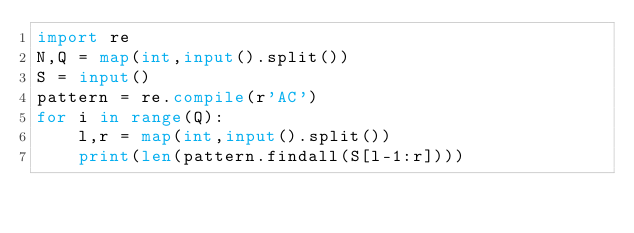Convert code to text. <code><loc_0><loc_0><loc_500><loc_500><_Python_>import re
N,Q = map(int,input().split())
S = input()
pattern = re.compile(r'AC')
for i in range(Q):
    l,r = map(int,input().split())
    print(len(pattern.findall(S[l-1:r])))</code> 